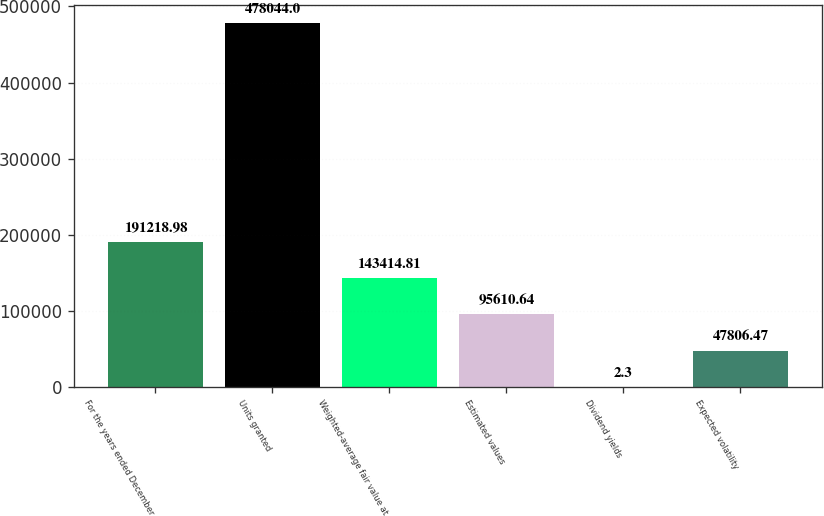Convert chart to OTSL. <chart><loc_0><loc_0><loc_500><loc_500><bar_chart><fcel>For the years ended December<fcel>Units granted<fcel>Weighted-average fair value at<fcel>Estimated values<fcel>Dividend yields<fcel>Expected volatility<nl><fcel>191219<fcel>478044<fcel>143415<fcel>95610.6<fcel>2.3<fcel>47806.5<nl></chart> 